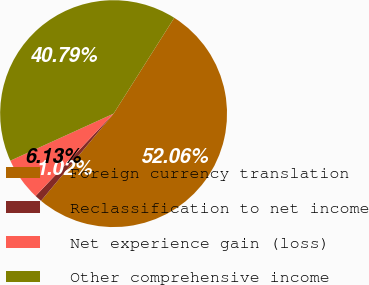<chart> <loc_0><loc_0><loc_500><loc_500><pie_chart><fcel>Foreign currency translation<fcel>Reclassification to net income<fcel>Net experience gain (loss)<fcel>Other comprehensive income<nl><fcel>52.06%<fcel>1.02%<fcel>6.13%<fcel>40.79%<nl></chart> 